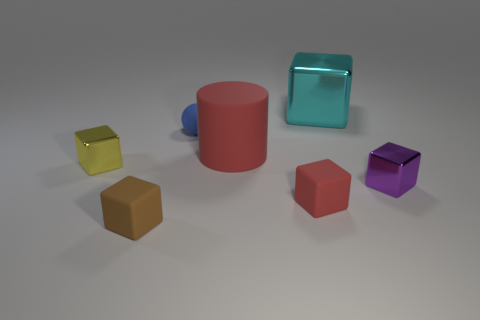Add 1 large metallic balls. How many objects exist? 8 Subtract all large metal blocks. How many blocks are left? 4 Add 3 red matte blocks. How many red matte blocks are left? 4 Add 5 big blue blocks. How many big blue blocks exist? 5 Subtract all brown blocks. How many blocks are left? 4 Subtract 1 cyan cubes. How many objects are left? 6 Subtract all blocks. How many objects are left? 2 Subtract 1 cylinders. How many cylinders are left? 0 Subtract all gray balls. Subtract all red cylinders. How many balls are left? 1 Subtract all yellow spheres. How many brown blocks are left? 1 